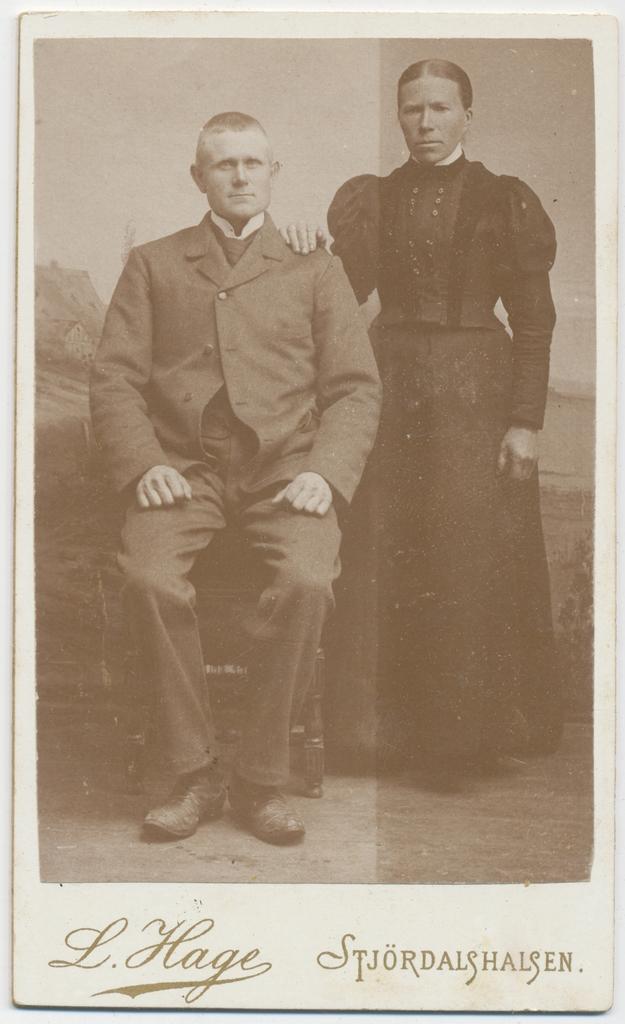Describe this image in one or two sentences. This is an old black and white image. I can see a man sitting on a chair and woman standing. In the background, there is a poster. At the bottom of the image, I can see the letters. 